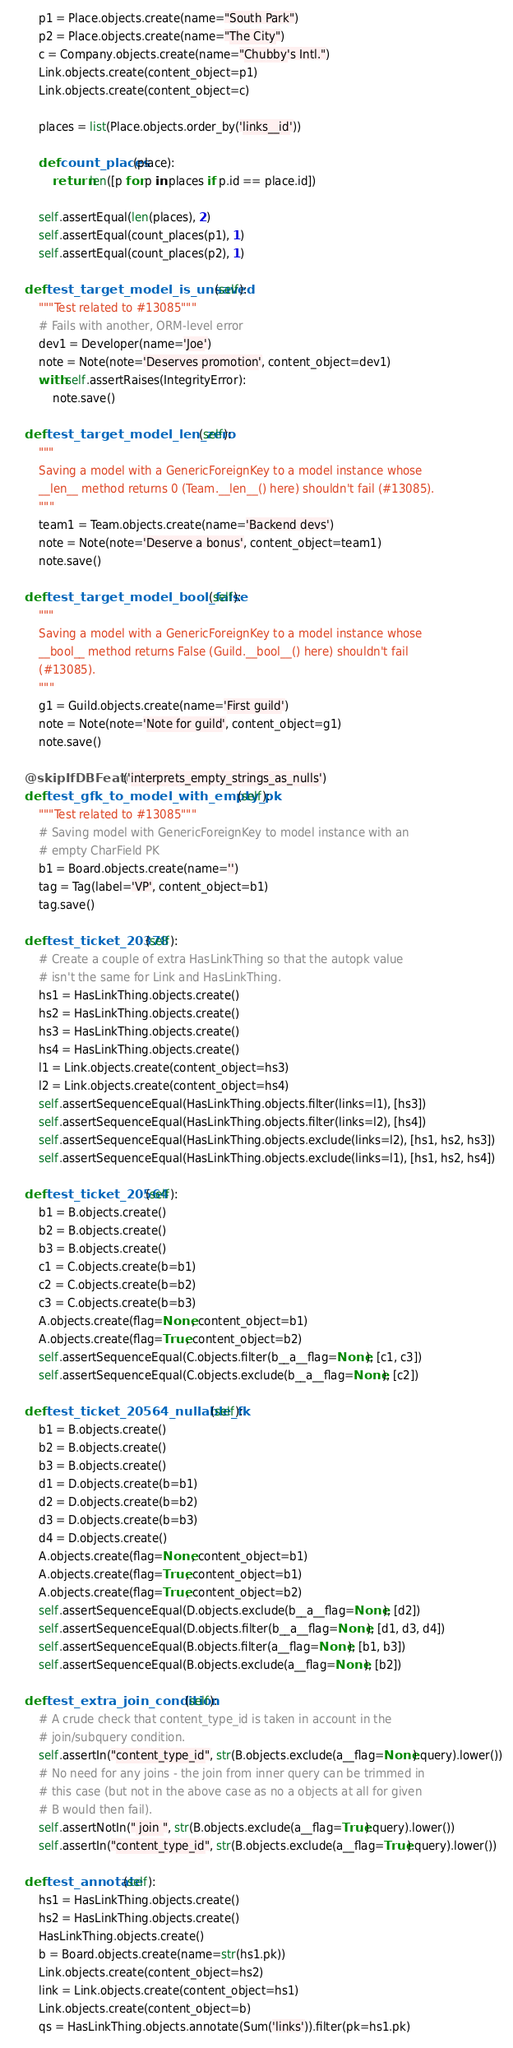<code> <loc_0><loc_0><loc_500><loc_500><_Python_>        p1 = Place.objects.create(name="South Park")
        p2 = Place.objects.create(name="The City")
        c = Company.objects.create(name="Chubby's Intl.")
        Link.objects.create(content_object=p1)
        Link.objects.create(content_object=c)

        places = list(Place.objects.order_by('links__id'))

        def count_places(place):
            return len([p for p in places if p.id == place.id])

        self.assertEqual(len(places), 2)
        self.assertEqual(count_places(p1), 1)
        self.assertEqual(count_places(p2), 1)

    def test_target_model_is_unsaved(self):
        """Test related to #13085"""
        # Fails with another, ORM-level error
        dev1 = Developer(name='Joe')
        note = Note(note='Deserves promotion', content_object=dev1)
        with self.assertRaises(IntegrityError):
            note.save()

    def test_target_model_len_zero(self):
        """
        Saving a model with a GenericForeignKey to a model instance whose
        __len__ method returns 0 (Team.__len__() here) shouldn't fail (#13085).
        """
        team1 = Team.objects.create(name='Backend devs')
        note = Note(note='Deserve a bonus', content_object=team1)
        note.save()

    def test_target_model_bool_false(self):
        """
        Saving a model with a GenericForeignKey to a model instance whose
        __bool__ method returns False (Guild.__bool__() here) shouldn't fail
        (#13085).
        """
        g1 = Guild.objects.create(name='First guild')
        note = Note(note='Note for guild', content_object=g1)
        note.save()

    @skipIfDBFeature('interprets_empty_strings_as_nulls')
    def test_gfk_to_model_with_empty_pk(self):
        """Test related to #13085"""
        # Saving model with GenericForeignKey to model instance with an
        # empty CharField PK
        b1 = Board.objects.create(name='')
        tag = Tag(label='VP', content_object=b1)
        tag.save()

    def test_ticket_20378(self):
        # Create a couple of extra HasLinkThing so that the autopk value
        # isn't the same for Link and HasLinkThing.
        hs1 = HasLinkThing.objects.create()
        hs2 = HasLinkThing.objects.create()
        hs3 = HasLinkThing.objects.create()
        hs4 = HasLinkThing.objects.create()
        l1 = Link.objects.create(content_object=hs3)
        l2 = Link.objects.create(content_object=hs4)
        self.assertSequenceEqual(HasLinkThing.objects.filter(links=l1), [hs3])
        self.assertSequenceEqual(HasLinkThing.objects.filter(links=l2), [hs4])
        self.assertSequenceEqual(HasLinkThing.objects.exclude(links=l2), [hs1, hs2, hs3])
        self.assertSequenceEqual(HasLinkThing.objects.exclude(links=l1), [hs1, hs2, hs4])

    def test_ticket_20564(self):
        b1 = B.objects.create()
        b2 = B.objects.create()
        b3 = B.objects.create()
        c1 = C.objects.create(b=b1)
        c2 = C.objects.create(b=b2)
        c3 = C.objects.create(b=b3)
        A.objects.create(flag=None, content_object=b1)
        A.objects.create(flag=True, content_object=b2)
        self.assertSequenceEqual(C.objects.filter(b__a__flag=None), [c1, c3])
        self.assertSequenceEqual(C.objects.exclude(b__a__flag=None), [c2])

    def test_ticket_20564_nullable_fk(self):
        b1 = B.objects.create()
        b2 = B.objects.create()
        b3 = B.objects.create()
        d1 = D.objects.create(b=b1)
        d2 = D.objects.create(b=b2)
        d3 = D.objects.create(b=b3)
        d4 = D.objects.create()
        A.objects.create(flag=None, content_object=b1)
        A.objects.create(flag=True, content_object=b1)
        A.objects.create(flag=True, content_object=b2)
        self.assertSequenceEqual(D.objects.exclude(b__a__flag=None), [d2])
        self.assertSequenceEqual(D.objects.filter(b__a__flag=None), [d1, d3, d4])
        self.assertSequenceEqual(B.objects.filter(a__flag=None), [b1, b3])
        self.assertSequenceEqual(B.objects.exclude(a__flag=None), [b2])

    def test_extra_join_condition(self):
        # A crude check that content_type_id is taken in account in the
        # join/subquery condition.
        self.assertIn("content_type_id", str(B.objects.exclude(a__flag=None).query).lower())
        # No need for any joins - the join from inner query can be trimmed in
        # this case (but not in the above case as no a objects at all for given
        # B would then fail).
        self.assertNotIn(" join ", str(B.objects.exclude(a__flag=True).query).lower())
        self.assertIn("content_type_id", str(B.objects.exclude(a__flag=True).query).lower())

    def test_annotate(self):
        hs1 = HasLinkThing.objects.create()
        hs2 = HasLinkThing.objects.create()
        HasLinkThing.objects.create()
        b = Board.objects.create(name=str(hs1.pk))
        Link.objects.create(content_object=hs2)
        link = Link.objects.create(content_object=hs1)
        Link.objects.create(content_object=b)
        qs = HasLinkThing.objects.annotate(Sum('links')).filter(pk=hs1.pk)</code> 